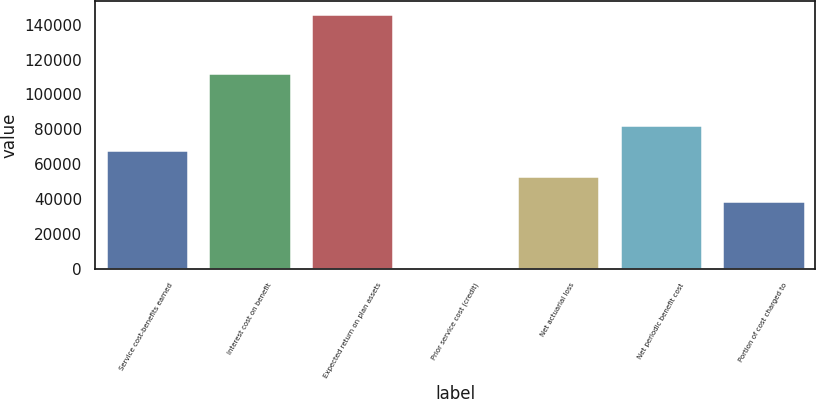Convert chart to OTSL. <chart><loc_0><loc_0><loc_500><loc_500><bar_chart><fcel>Service cost-benefits earned<fcel>Interest cost on benefit<fcel>Expected return on plan assets<fcel>Prior service cost (credit)<fcel>Net actuarial loss<fcel>Net periodic benefit cost<fcel>Portion of cost charged to<nl><fcel>68015.2<fcel>112392<fcel>146333<fcel>1097<fcel>53491.6<fcel>82538.8<fcel>38968<nl></chart> 